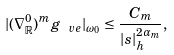Convert formula to latex. <formula><loc_0><loc_0><loc_500><loc_500>| ( \nabla ^ { 0 } _ { \mathbb { R } } ) ^ { m } g _ { \ v e } | _ { \omega _ { 0 } } \leq \frac { C _ { m } } { | s | ^ { 2 \alpha _ { m } } _ { h } } , \\</formula> 